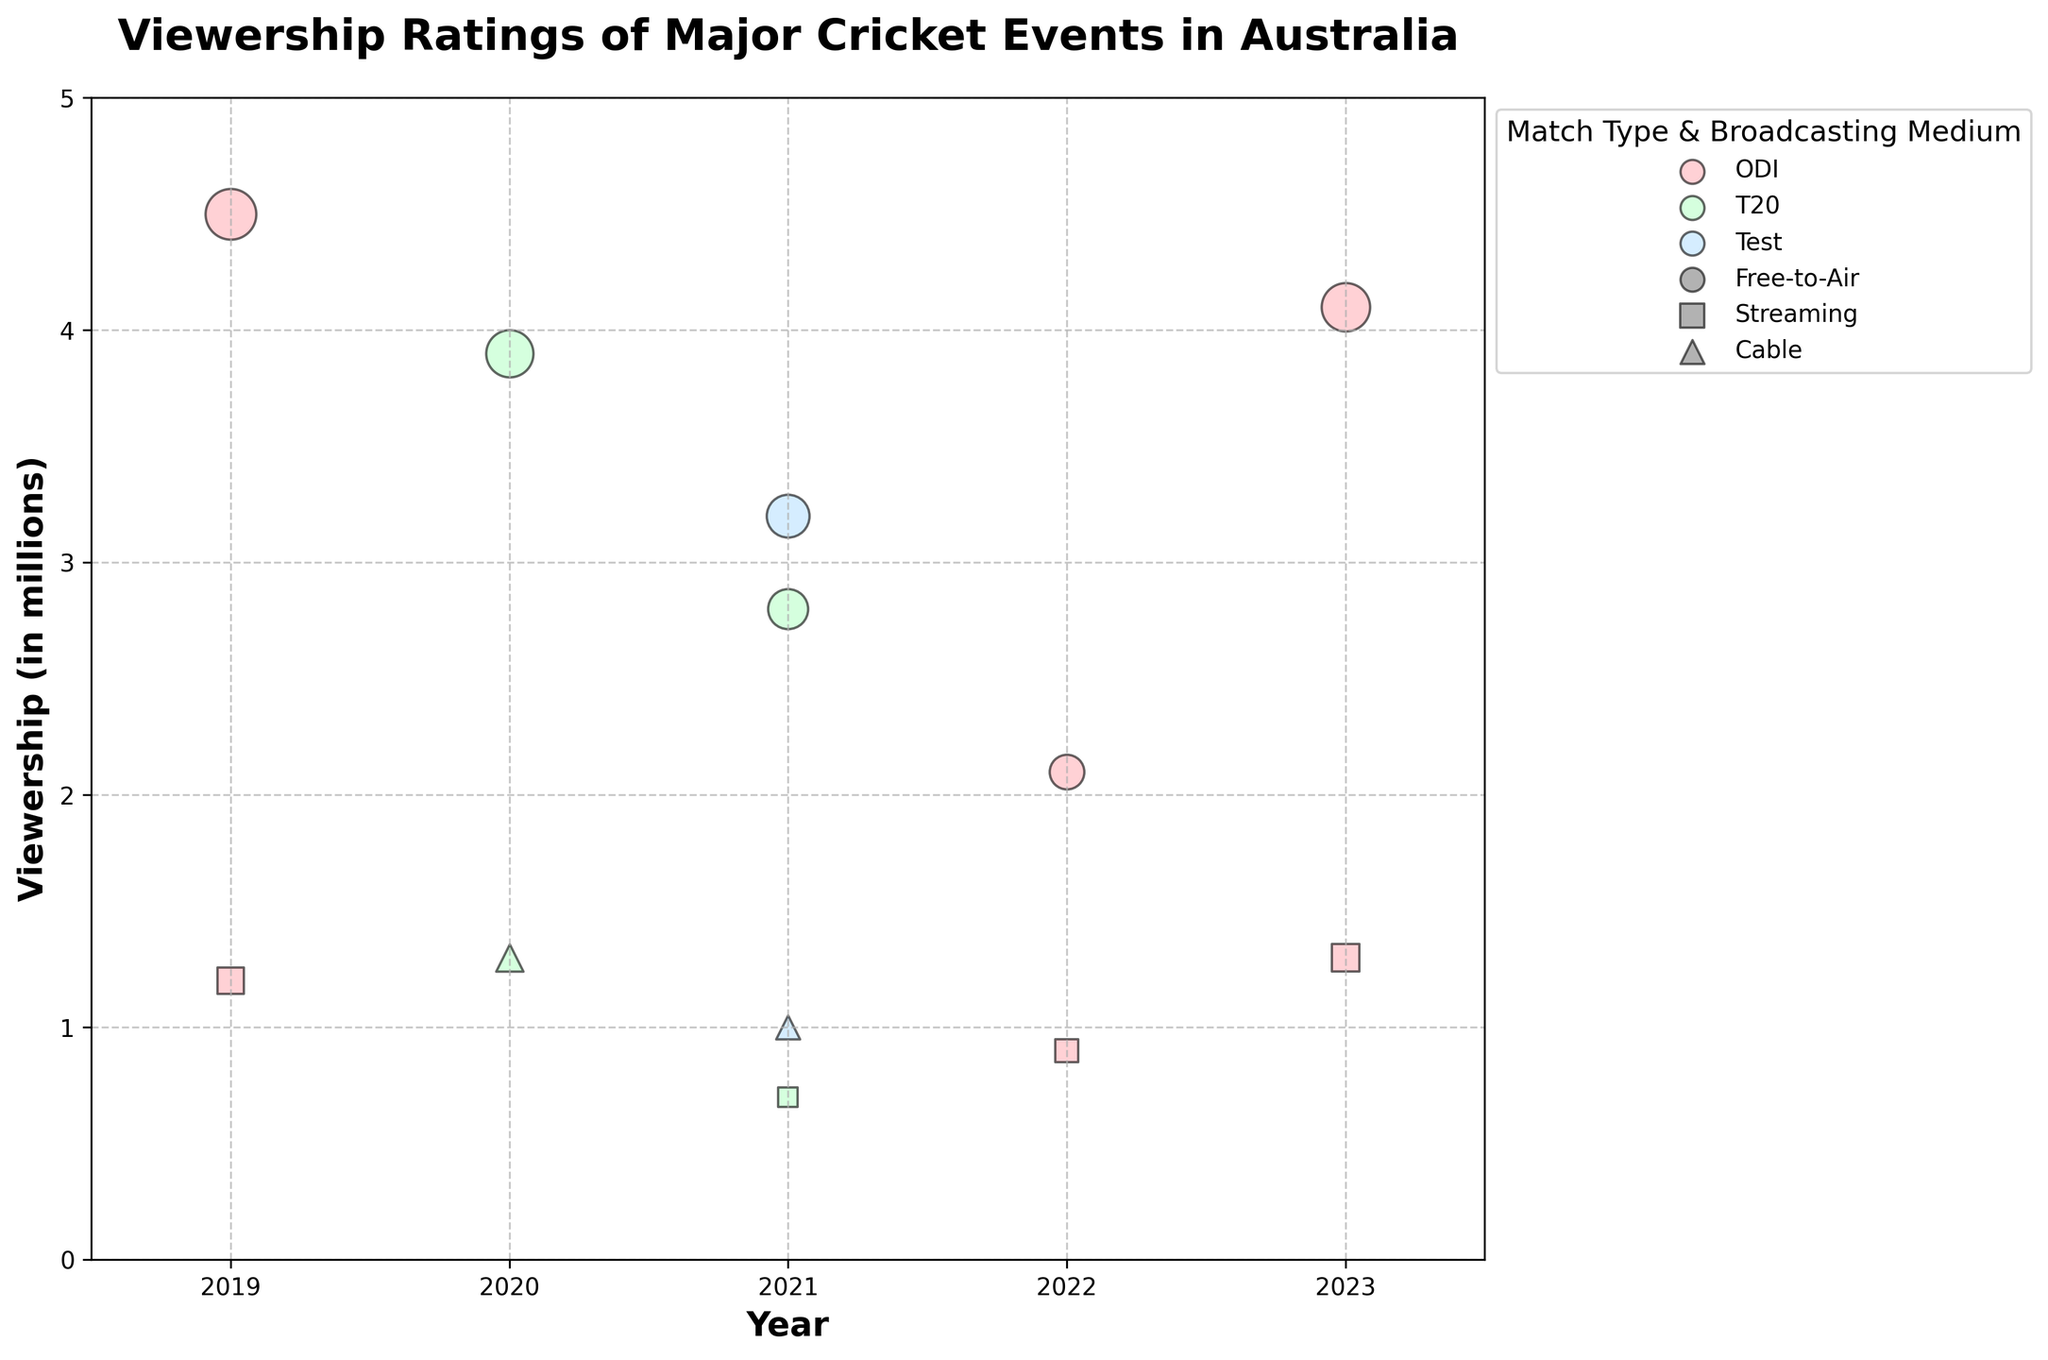What is the title of the chart? The title of the chart is directly stated at the top of the figure in bold.
Answer: Viewership Ratings of Major Cricket Events in Australia What are the ranges for the x-axis and y-axis? The x-axis ranges from 2018.5 to 2023.5, and the y-axis ranges from 0 to 5, as observed at the bottom and left sides of the figure respectively.
Answer: 2018.5-2023.5 and 0-5 Which match type had the highest viewership in 2019? The largest bubble in 2019 indicates the highest viewership. The pink color represents ODI match type.
Answer: ODI How many events had a viewership rating above 4 million in 2019? There is one large, pink bubble above the 4-million mark in 2019, which represents an ODI event.
Answer: 1 What colors are used to represent different match types? The legend shows the colors associated with each match type: ODI is pink (#FFB3BA), T20 is light green (#BAFFC9), and Test is light blue (#BAE1FF).
Answer: Pink for ODI, Light green for T20, Light blue for Test Which year had the highest number of events with viewership ratings listed? By counting the bubbles for each year, 2021 has the most bubbles, indicating the highest number of events in that year.
Answer: 2021 What is the viewership rating for the ICC T20 World Cup in 2020 on Free-to-Air broadcasting medium? A green circle (representing T20, Free-to-Air) in 2020 shows a viewership of just below 4 million, and the exact value from the data is 3.9 million.
Answer: 3.9 million Compare the viewership ratings of the ICC Cricket World Cup (ODI) via Free-to-Air in 2019 and 2023. Which year had a higher viewership? The larger pink circles for Free-to-Air in 2019 and 2023 represent the ratings. The 2019 circle is slightly larger (4.5 million) compared to 2023 (4.1 million), indicating higher viewership in 2019.
Answer: 2019 What was the total viewership of the ICC Cricket World Cup in 2019 across both broadcasting mediums? Add the viewership for Free-to-Air (4.5 million) and Streaming (1.2 million) from 2019. 4.5 + 1.2 = 5.7 million.
Answer: 5.7 million Which match type had the lowest viewership in 2021 and what medium was used? The smallest bubble in 2021 is light blue with a triangle shape, representing a Test match on Cable with a viewership of 1.0 million.
Answer: Test on Cable 